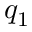Convert formula to latex. <formula><loc_0><loc_0><loc_500><loc_500>q _ { 1 }</formula> 